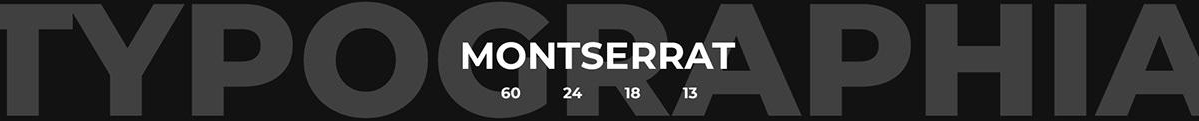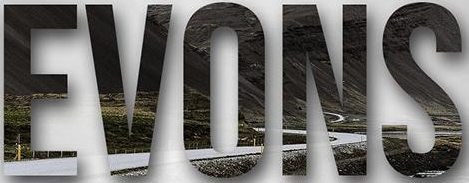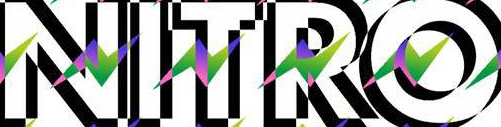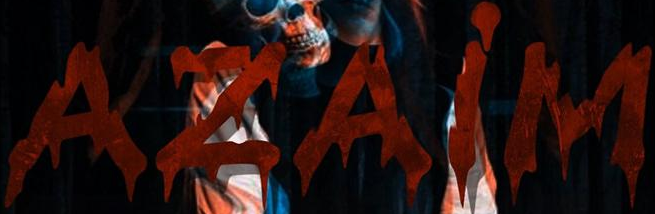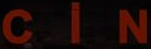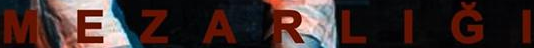What text is displayed in these images sequentially, separated by a semicolon? TYPOGRAPHIA; EVONS; NITRO; AZAiM; CiN; MEZARLIĞI 